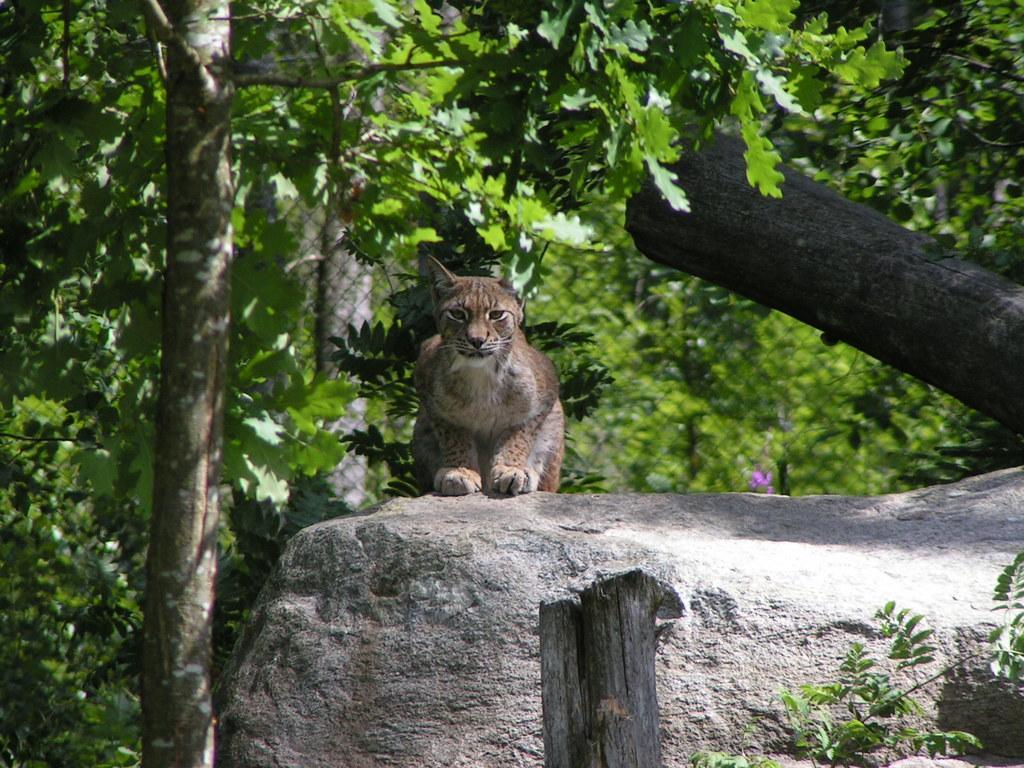Please provide a concise description of this image. In front of the image there is a wooden pole. Beside that there are leaves. There is a rock with an animal on it. In the background there are trees and also there is fencing. On the right side of the image there is a wooden pole. 